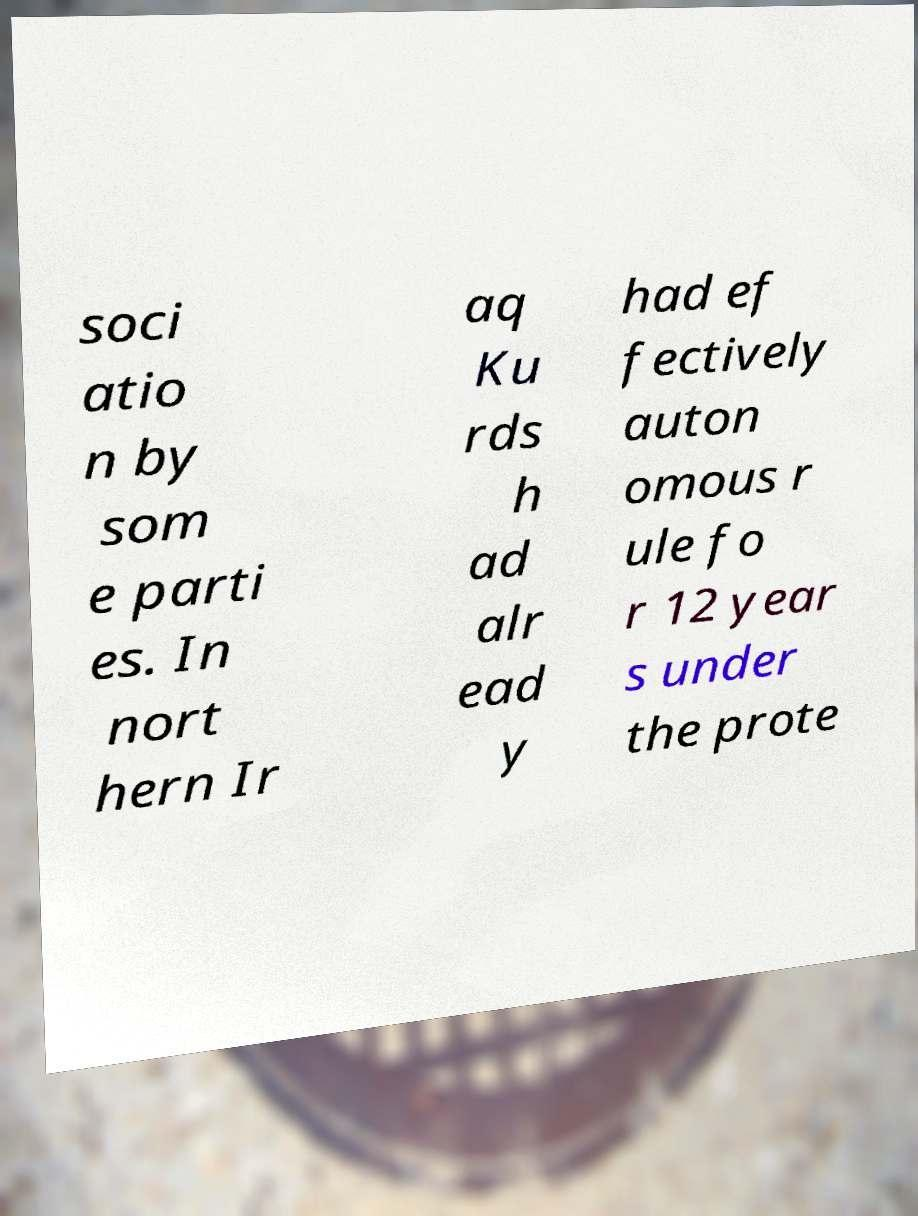There's text embedded in this image that I need extracted. Can you transcribe it verbatim? soci atio n by som e parti es. In nort hern Ir aq Ku rds h ad alr ead y had ef fectively auton omous r ule fo r 12 year s under the prote 